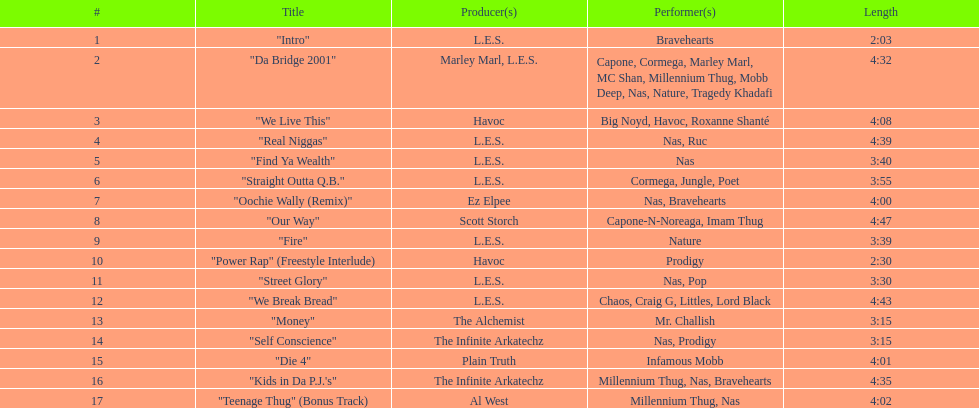Parse the full table. {'header': ['#', 'Title', 'Producer(s)', 'Performer(s)', 'Length'], 'rows': [['1', '"Intro"', 'L.E.S.', 'Bravehearts', '2:03'], ['2', '"Da Bridge 2001"', 'Marley Marl, L.E.S.', 'Capone, Cormega, Marley Marl, MC Shan, Millennium Thug, Mobb Deep, Nas, Nature, Tragedy Khadafi', '4:32'], ['3', '"We Live This"', 'Havoc', 'Big Noyd, Havoc, Roxanne Shanté', '4:08'], ['4', '"Real Niggas"', 'L.E.S.', 'Nas, Ruc', '4:39'], ['5', '"Find Ya Wealth"', 'L.E.S.', 'Nas', '3:40'], ['6', '"Straight Outta Q.B."', 'L.E.S.', 'Cormega, Jungle, Poet', '3:55'], ['7', '"Oochie Wally (Remix)"', 'Ez Elpee', 'Nas, Bravehearts', '4:00'], ['8', '"Our Way"', 'Scott Storch', 'Capone-N-Noreaga, Imam Thug', '4:47'], ['9', '"Fire"', 'L.E.S.', 'Nature', '3:39'], ['10', '"Power Rap" (Freestyle Interlude)', 'Havoc', 'Prodigy', '2:30'], ['11', '"Street Glory"', 'L.E.S.', 'Nas, Pop', '3:30'], ['12', '"We Break Bread"', 'L.E.S.', 'Chaos, Craig G, Littles, Lord Black', '4:43'], ['13', '"Money"', 'The Alchemist', 'Mr. Challish', '3:15'], ['14', '"Self Conscience"', 'The Infinite Arkatechz', 'Nas, Prodigy', '3:15'], ['15', '"Die 4"', 'Plain Truth', 'Infamous Mobb', '4:01'], ['16', '"Kids in Da P.J.\'s"', 'The Infinite Arkatechz', 'Millennium Thug, Nas, Bravehearts', '4:35'], ['17', '"Teenage Thug" (Bonus Track)', 'Al West', 'Millennium Thug, Nas', '4:02']]} Which tune is more extended, "money" or "die 4"? "Die 4". 